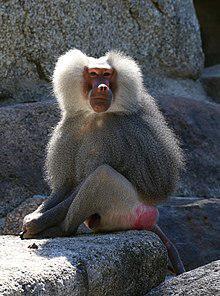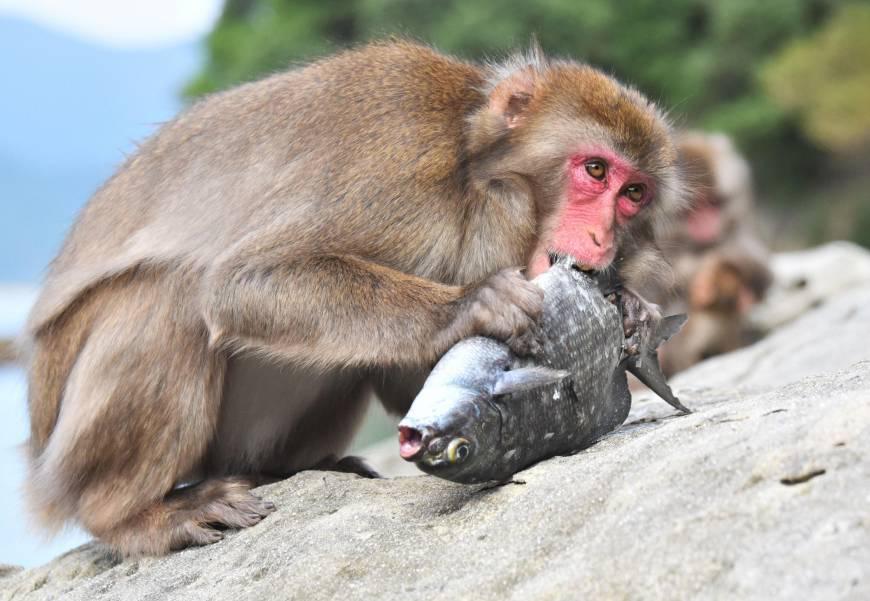The first image is the image on the left, the second image is the image on the right. For the images shown, is this caption "The monkey in the right image is eating something." true? Answer yes or no. Yes. The first image is the image on the left, the second image is the image on the right. Examine the images to the left and right. Is the description "One image shows at least three baboons posed close together, and the other image shows one forward-facing baboon sitting with bent knees." accurate? Answer yes or no. No. 